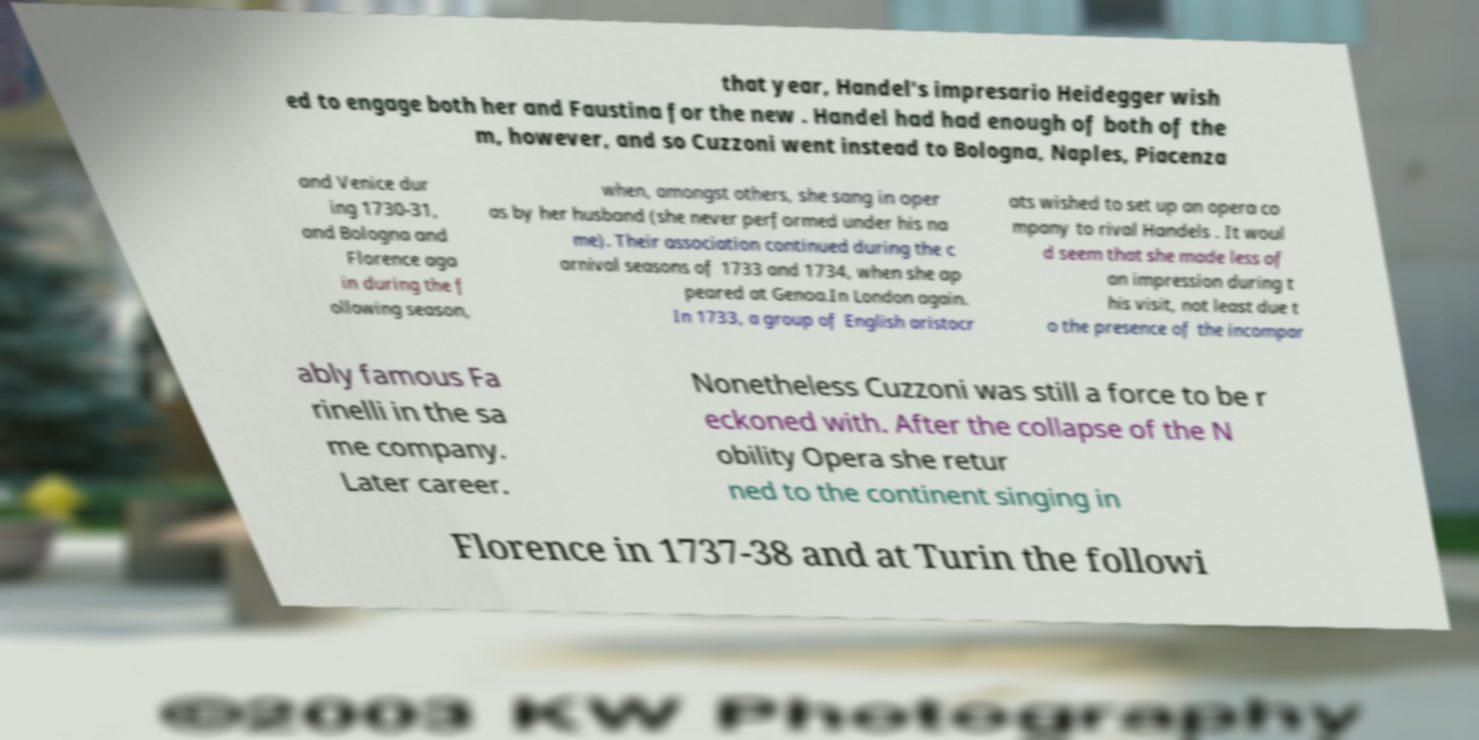Please identify and transcribe the text found in this image. that year, Handel's impresario Heidegger wish ed to engage both her and Faustina for the new . Handel had had enough of both of the m, however, and so Cuzzoni went instead to Bologna, Naples, Piacenza and Venice dur ing 1730-31, and Bologna and Florence aga in during the f ollowing season, when, amongst others, she sang in oper as by her husband (she never performed under his na me). Their association continued during the c arnival seasons of 1733 and 1734, when she ap peared at Genoa.In London again. In 1733, a group of English aristocr ats wished to set up an opera co mpany to rival Handels . It woul d seem that she made less of an impression during t his visit, not least due t o the presence of the incompar ably famous Fa rinelli in the sa me company. Later career. Nonetheless Cuzzoni was still a force to be r eckoned with. After the collapse of the N obility Opera she retur ned to the continent singing in Florence in 1737-38 and at Turin the followi 